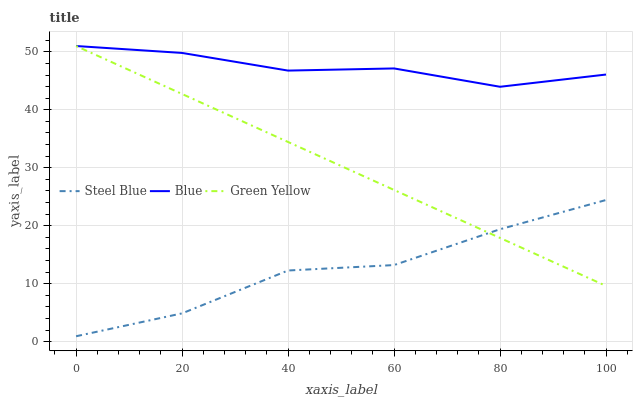Does Steel Blue have the minimum area under the curve?
Answer yes or no. Yes. Does Blue have the maximum area under the curve?
Answer yes or no. Yes. Does Green Yellow have the minimum area under the curve?
Answer yes or no. No. Does Green Yellow have the maximum area under the curve?
Answer yes or no. No. Is Green Yellow the smoothest?
Answer yes or no. Yes. Is Steel Blue the roughest?
Answer yes or no. Yes. Is Steel Blue the smoothest?
Answer yes or no. No. Is Green Yellow the roughest?
Answer yes or no. No. Does Steel Blue have the lowest value?
Answer yes or no. Yes. Does Green Yellow have the lowest value?
Answer yes or no. No. Does Green Yellow have the highest value?
Answer yes or no. Yes. Does Steel Blue have the highest value?
Answer yes or no. No. Is Steel Blue less than Blue?
Answer yes or no. Yes. Is Blue greater than Steel Blue?
Answer yes or no. Yes. Does Green Yellow intersect Blue?
Answer yes or no. Yes. Is Green Yellow less than Blue?
Answer yes or no. No. Is Green Yellow greater than Blue?
Answer yes or no. No. Does Steel Blue intersect Blue?
Answer yes or no. No. 